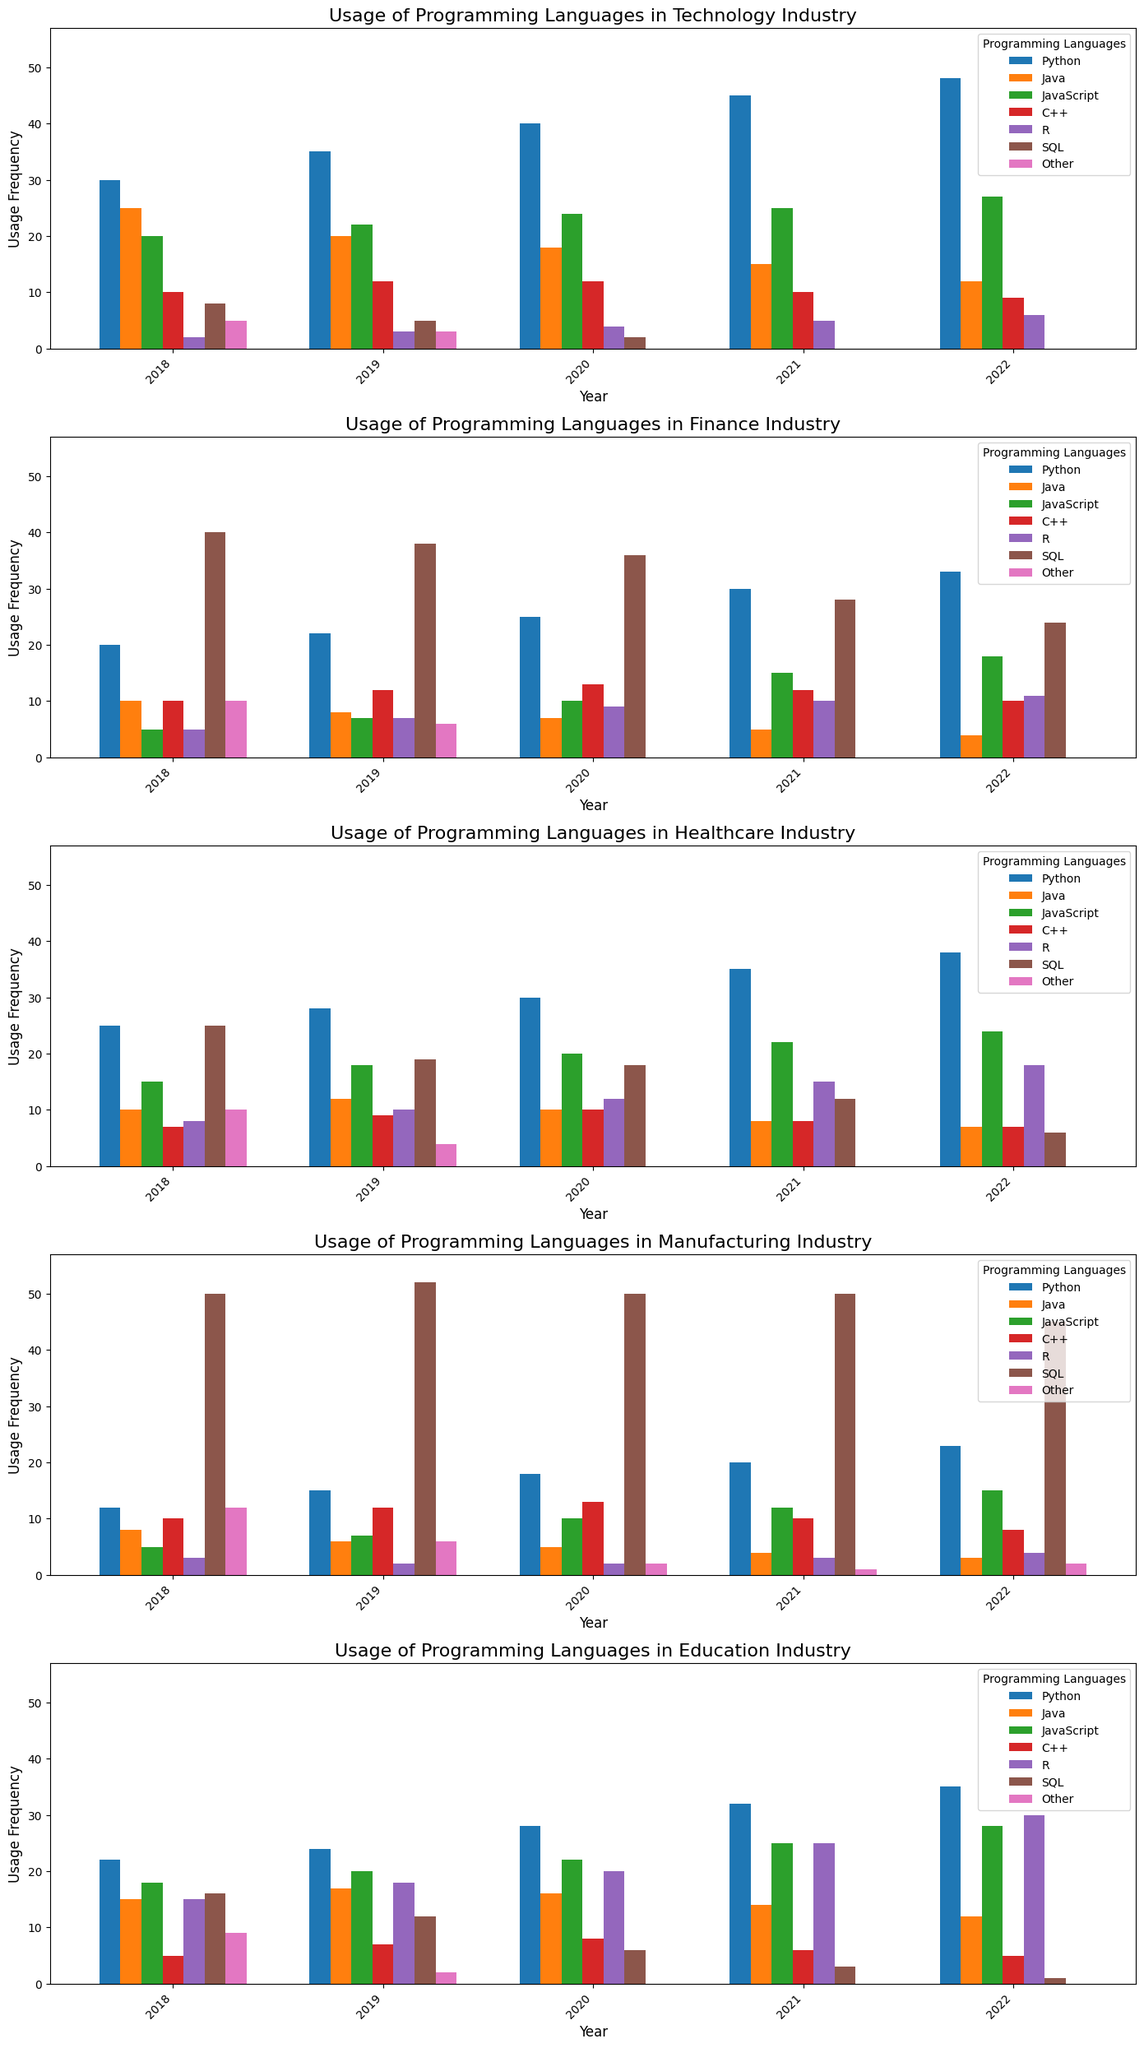How has the usage of Python changed from 2018 to 2022 in the Technology industry? To determine the change in Python usage, we need to compare the heights of the bars representing Python for the years 2018 and 2022 in the Technology industry subplot. In 2018, Python usage was at 30 and in 2022, it increased to 48. The change is 48 - 30.
Answer: Increase by 18 Comparing Java and JavaScript in the Finance industry, which language had the highest frequency in 2021? We examine the bars for Java and JavaScript for the year 2021 in the Finance industry subplot. Java had a frequency of 5, while JavaScript had a frequency of 15.
Answer: JavaScript What is the sum of SQL usage in the Healthcare industry from 2018 to 2022? SQL usage values for Healthcare industry from 2018 to 2022 are 25, 19, 18, 12, and 6. Adding these values gives 25 + 19 + 18 + 12 + 6.
Answer: 80 Which programming language had the lowest usage in the Manufacturing industry in 2021? For 2021 in the Manufacturing industry subplot, we compare the heights of the bars. Java had the lowest usage with a value of 4.
Answer: Java What is the difference in R usage between the Education and Finance industries in 2022? For 2022, R usage in Education is 30 and in Finance is 11. We subtract these values to find the difference: 30 - 11.
Answer: 19 In the Technology industry, compare the Python usage in 2018 and 2019. Was there an increase or decrease, and by how much? Python usage in the Technology industry in 2018 was 30 and in 2019 was 35. The change is 35 - 30, which indicates an increase.
Answer: Increase by 5 What percentage increase is observed in JavaScript usage in the Healthcare industry from 2018 to 2022? JavaScript usage in the Healthcare industry in 2018 was 15 and in 2022 was 24. The percentage increase is calculated as ((24 - 15) / 15) * 100.
Answer: 60% Which language experienced a drop to zero usage in Technology from any year, and in which year did this happen? From 2018 to 2022 in the Technology industry subplot, SQL dropped to zero usage in 2021 and 2022.
Answer: SQL in 2021 